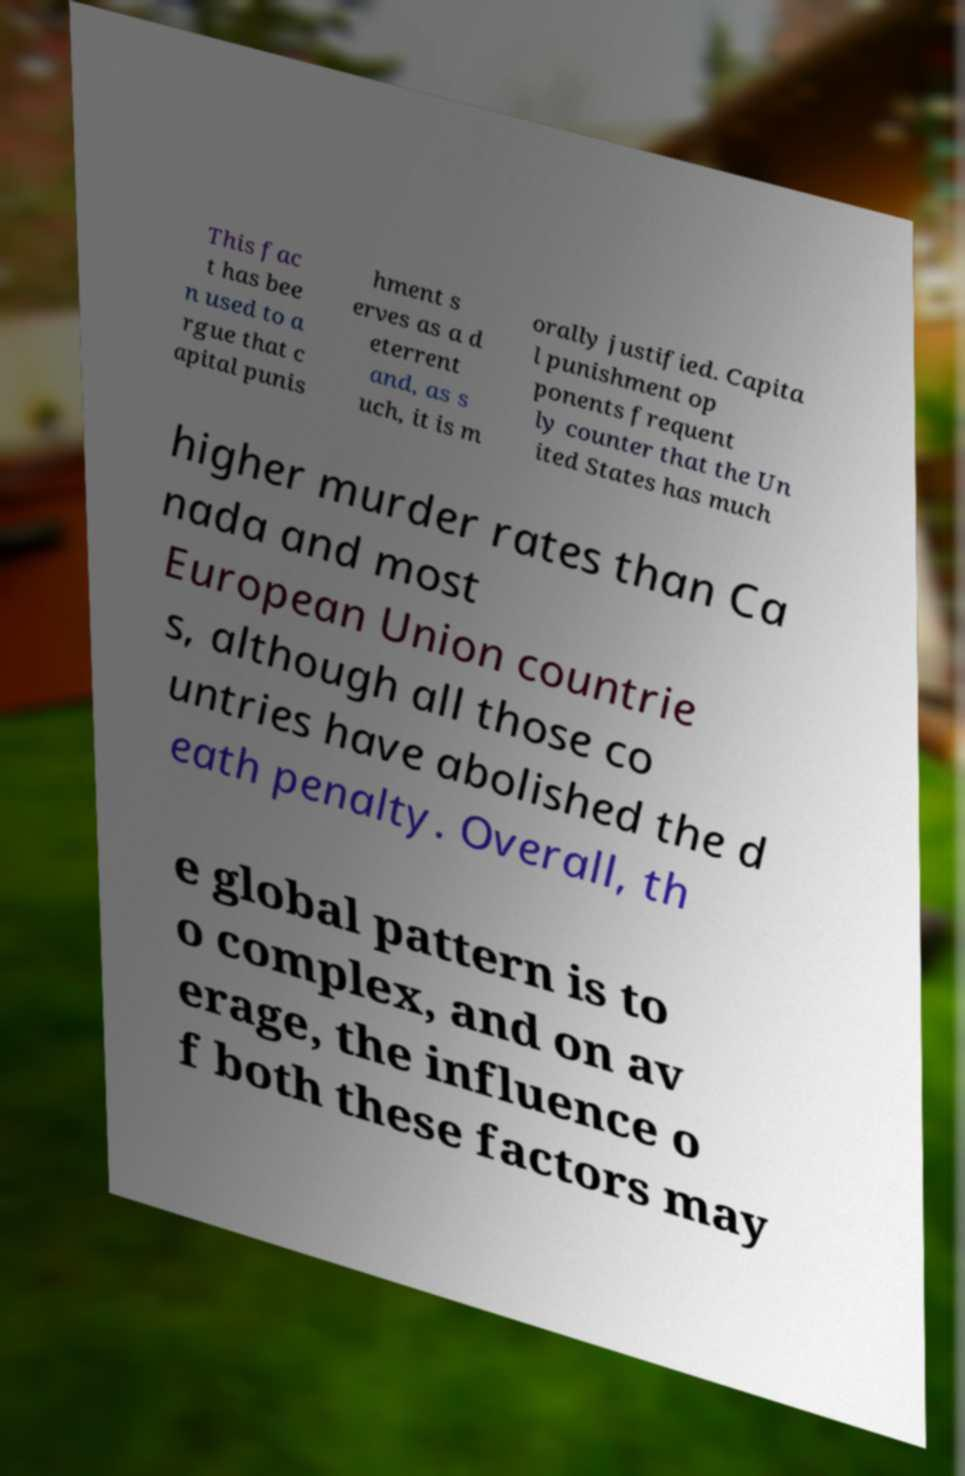What messages or text are displayed in this image? I need them in a readable, typed format. This fac t has bee n used to a rgue that c apital punis hment s erves as a d eterrent and, as s uch, it is m orally justified. Capita l punishment op ponents frequent ly counter that the Un ited States has much higher murder rates than Ca nada and most European Union countrie s, although all those co untries have abolished the d eath penalty. Overall, th e global pattern is to o complex, and on av erage, the influence o f both these factors may 